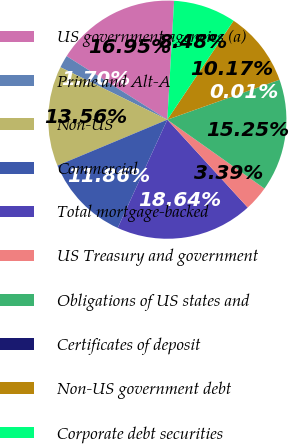<chart> <loc_0><loc_0><loc_500><loc_500><pie_chart><fcel>US government agencies (a)<fcel>Prime and Alt-A<fcel>Non-US<fcel>Commercial<fcel>Total mortgage-backed<fcel>US Treasury and government<fcel>Obligations of US states and<fcel>Certificates of deposit<fcel>Non-US government debt<fcel>Corporate debt securities<nl><fcel>16.95%<fcel>1.7%<fcel>13.56%<fcel>11.86%<fcel>18.64%<fcel>3.39%<fcel>15.25%<fcel>0.01%<fcel>10.17%<fcel>8.48%<nl></chart> 